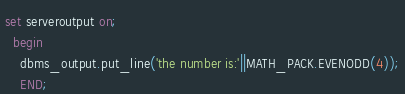<code> <loc_0><loc_0><loc_500><loc_500><_SQL_>set serveroutput on;
  begin
    dbms_output.put_line('the number is:'||MATH_PACK.EVENODD(4));
    END;</code> 